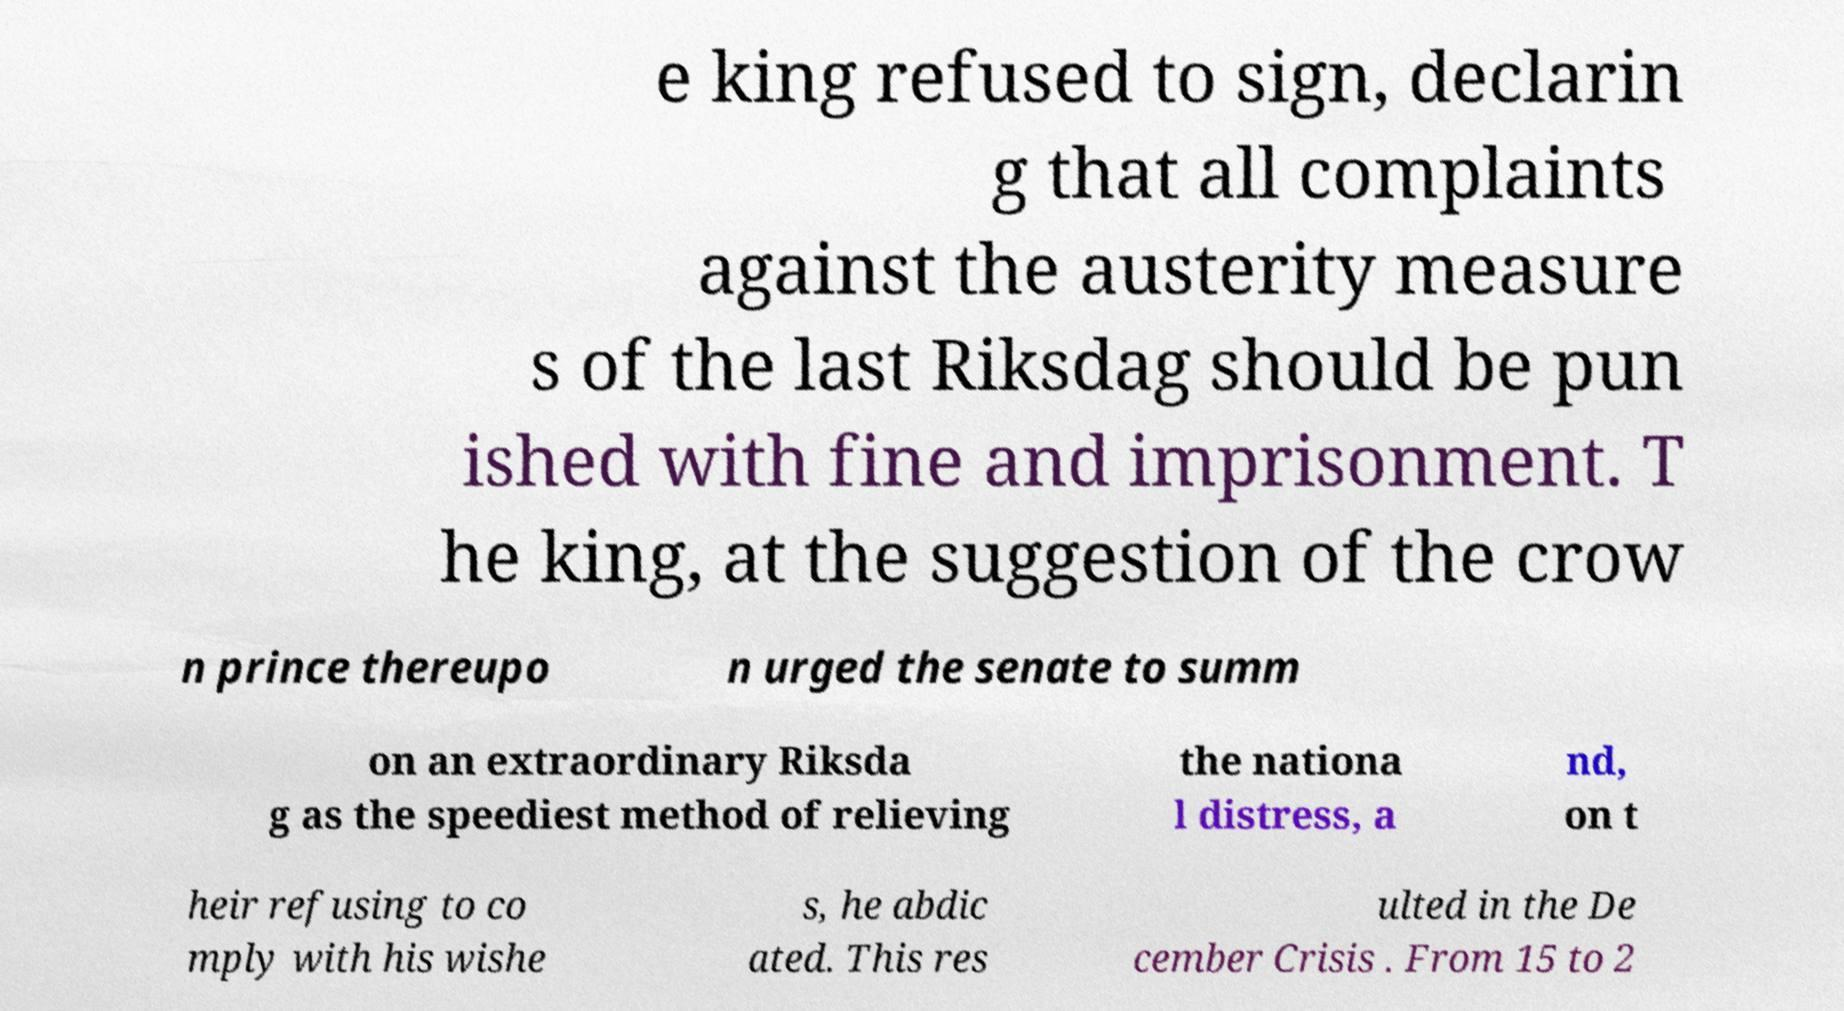Could you extract and type out the text from this image? e king refused to sign, declarin g that all complaints against the austerity measure s of the last Riksdag should be pun ished with fine and imprisonment. T he king, at the suggestion of the crow n prince thereupo n urged the senate to summ on an extraordinary Riksda g as the speediest method of relieving the nationa l distress, a nd, on t heir refusing to co mply with his wishe s, he abdic ated. This res ulted in the De cember Crisis . From 15 to 2 